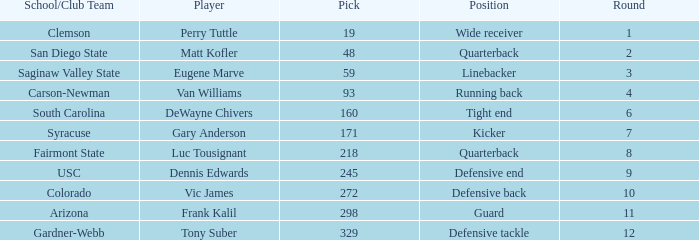Which player's pick is 160? DeWayne Chivers. 